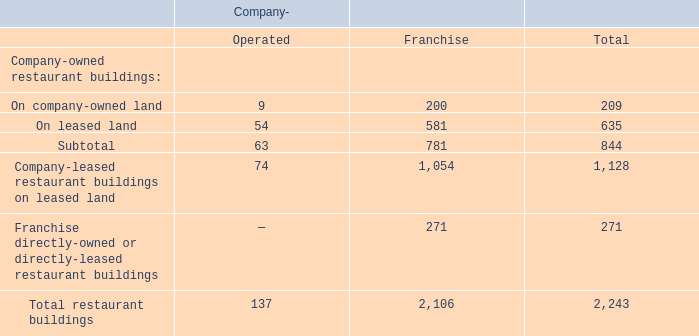Legislation and regulations regarding our products and ingredients, including the nutritional content of our products, could impact customer preferences and negatively impact our financial results.
Changes in government regulation and consumer eating habits may impact the ingredients and nutritional content of our menu offerings, or require us to disclose the nutritional content of our menu offerings. For example, a number of states, counties, and cities have enacted menu labeling laws requiring multi-unit restaurant operators to disclose certain nutritional information to customers, or have enacted legislation restricting the use of certain types of ingredients in restaurants. Furthermore, the Affordable Care Act requires chain restaurants to publish calorie information on their menus and menu boards. These and other requirements may increase our expenses, slow customers’ ordering process, or negatively influence the demand for our offerings; all of which can impact sales and profitability.
Compliance with current and future laws and regulations in a number of areas, including with respect to ingredients, nutritional content of our products, and packaging and serviceware may be costly and time-consuming. Additionally, if consumer health regulations change significantly, we may be required to modify our menu offerings or packaging, and as a result, may experience higher costs or reduced demand associated with such changes. Some government authorities are increasing regulations regarding trans-fats and sodium. While we have removed all artificial or “added during manufacturing” trans fats from our ingredients, some ingredients have naturally occurring trans-fats. Future requirements limiting trans-fats or sodium content may require us to change our menu offerings or switch to higher cost ingredients. These actions may hinder our ability to operate in some markets or to offer our full menu in these markets, which could have a material adverse effect on our business. If we fail to comply with such laws and regulations, our business could also experience a material adverse effect.
Failure to obtain and maintain required licenses and permits or to comply with food control regulations could lead to the loss of our food service licenses and, thereby, harm our business.
We are required, as a restaurant business, under state and local government regulations to obtain and maintain licenses, permits, and approvals to operate our businesses. Such regulations are subject to change from time to time. Any failure by us or our franchisees to obtain and maintain these licenses, permits, and approvals could adversely affect our financial results.
The following table sets forth information regarding our operating restaurant properties as of September 29, 2019:
What are the consequences if legislations and regulations target our products, ingredients and the nutritional content of our products? Impact customer preferences and negatively impact our financial results. What are the consequences if the company fails to obtain and maintain required licenses and permits or fails to comply with food regulations? Loss of our food service licenses and, thereby, harm our business. What is the grand total of both company-operated and franchise restaurants together? 2,243. What is the difference between the number of company-operated and franchise restaurants? 2,106 - 137 
Answer: 1969. What is the percentage constitution of company-operated restaurants among the total restaurants?
Answer scale should be: percent. 137/2,243 
Answer: 6.11. What is the percentage constitution of franchise restaurant on leased land in the total number of franchise buildings? 
Answer scale should be: percent. 581/2,106 
Answer: 27.59. 